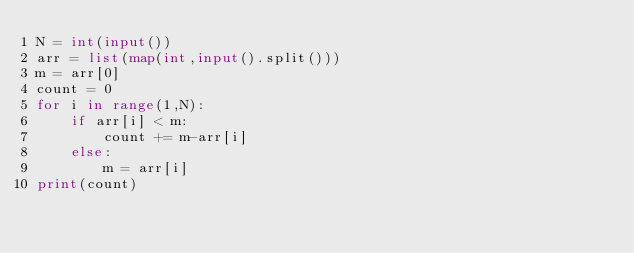Convert code to text. <code><loc_0><loc_0><loc_500><loc_500><_Python_>N = int(input())
arr = list(map(int,input().split()))
m = arr[0]
count = 0
for i in range(1,N):
    if arr[i] < m:
        count += m-arr[i]
    else:
        m = arr[i]
print(count)
</code> 